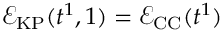Convert formula to latex. <formula><loc_0><loc_0><loc_500><loc_500>\mathcal { E } _ { K P } ( t ^ { 1 } , 1 ) = \mathcal { E } _ { C C } ( t ^ { 1 } )</formula> 